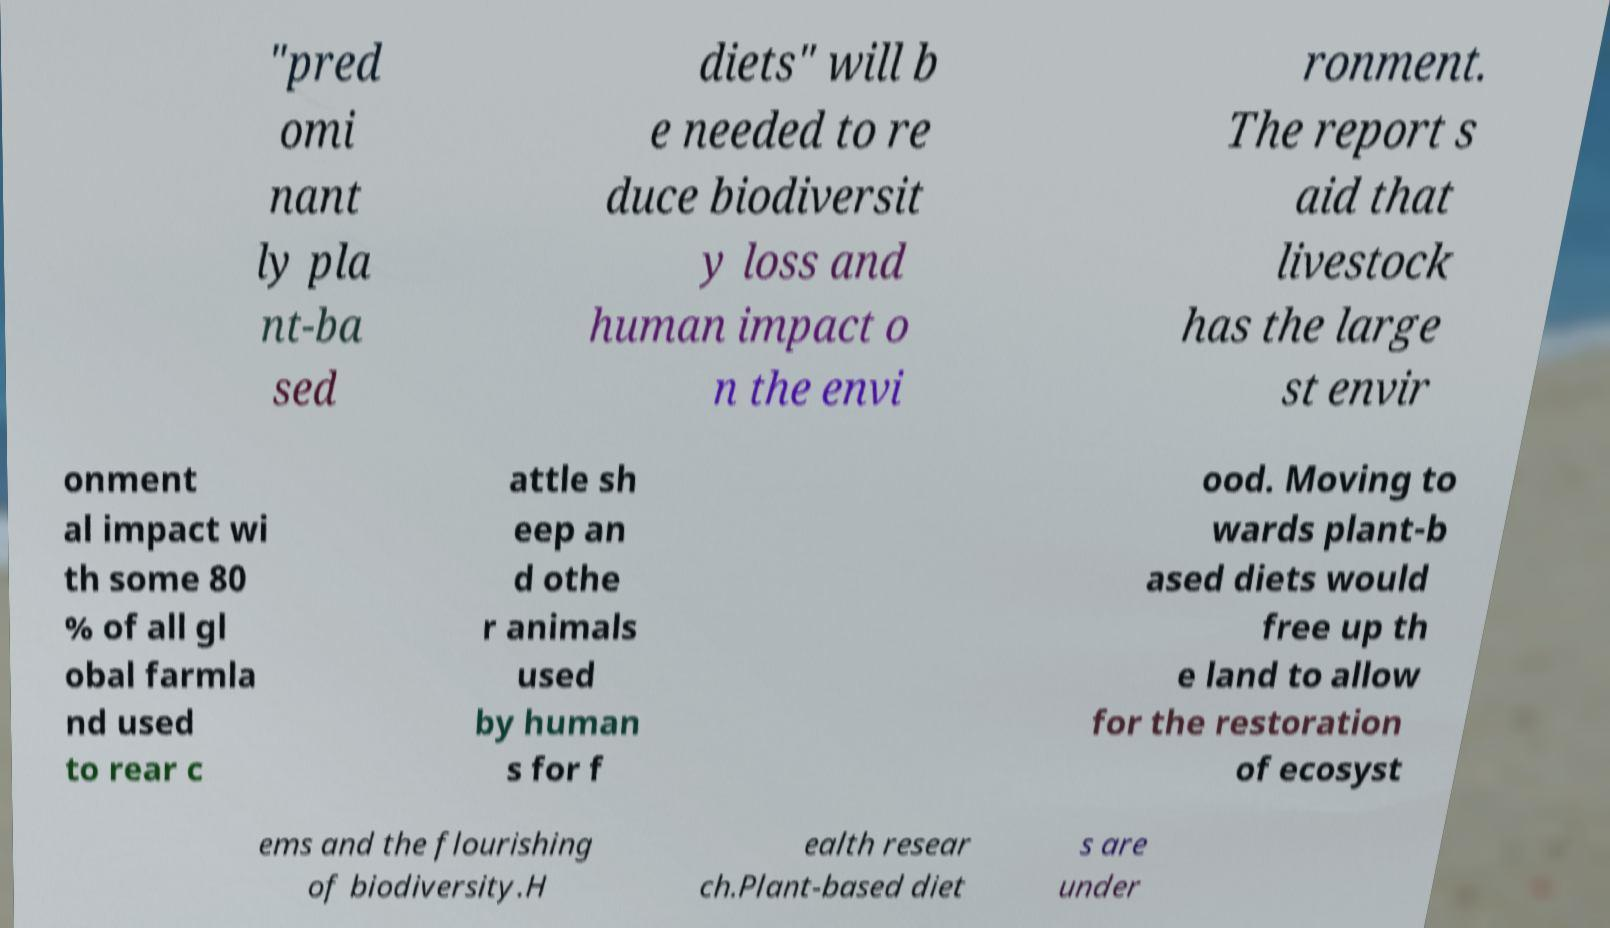Please identify and transcribe the text found in this image. "pred omi nant ly pla nt-ba sed diets" will b e needed to re duce biodiversit y loss and human impact o n the envi ronment. The report s aid that livestock has the large st envir onment al impact wi th some 80 % of all gl obal farmla nd used to rear c attle sh eep an d othe r animals used by human s for f ood. Moving to wards plant-b ased diets would free up th e land to allow for the restoration of ecosyst ems and the flourishing of biodiversity.H ealth resear ch.Plant-based diet s are under 